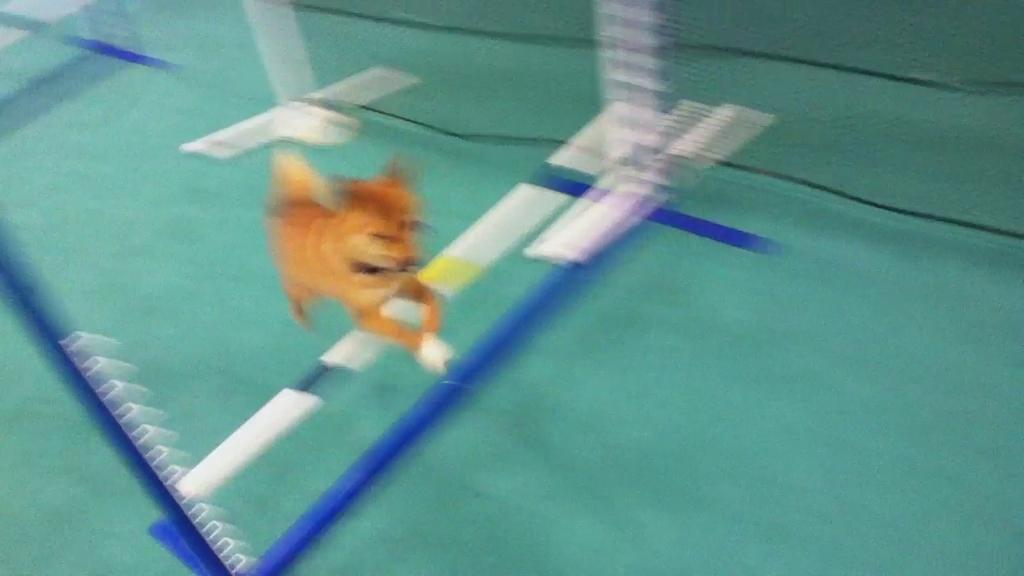What type of animal is in the image? There is a brown-colored dog in the image. What colors can be seen in the image besides the dog's color? There are white and blue-colored things in the image. How would you describe the quality of the image? The image is blurry. What type of destruction is the snail causing in the image? There is no snail present in the image, so it cannot be causing any destruction. What song is being sung by the dog in the image? There is no indication in the image that the dog is singing a song, so it cannot be determined from the image. 